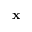Convert formula to latex. <formula><loc_0><loc_0><loc_500><loc_500>x</formula> 